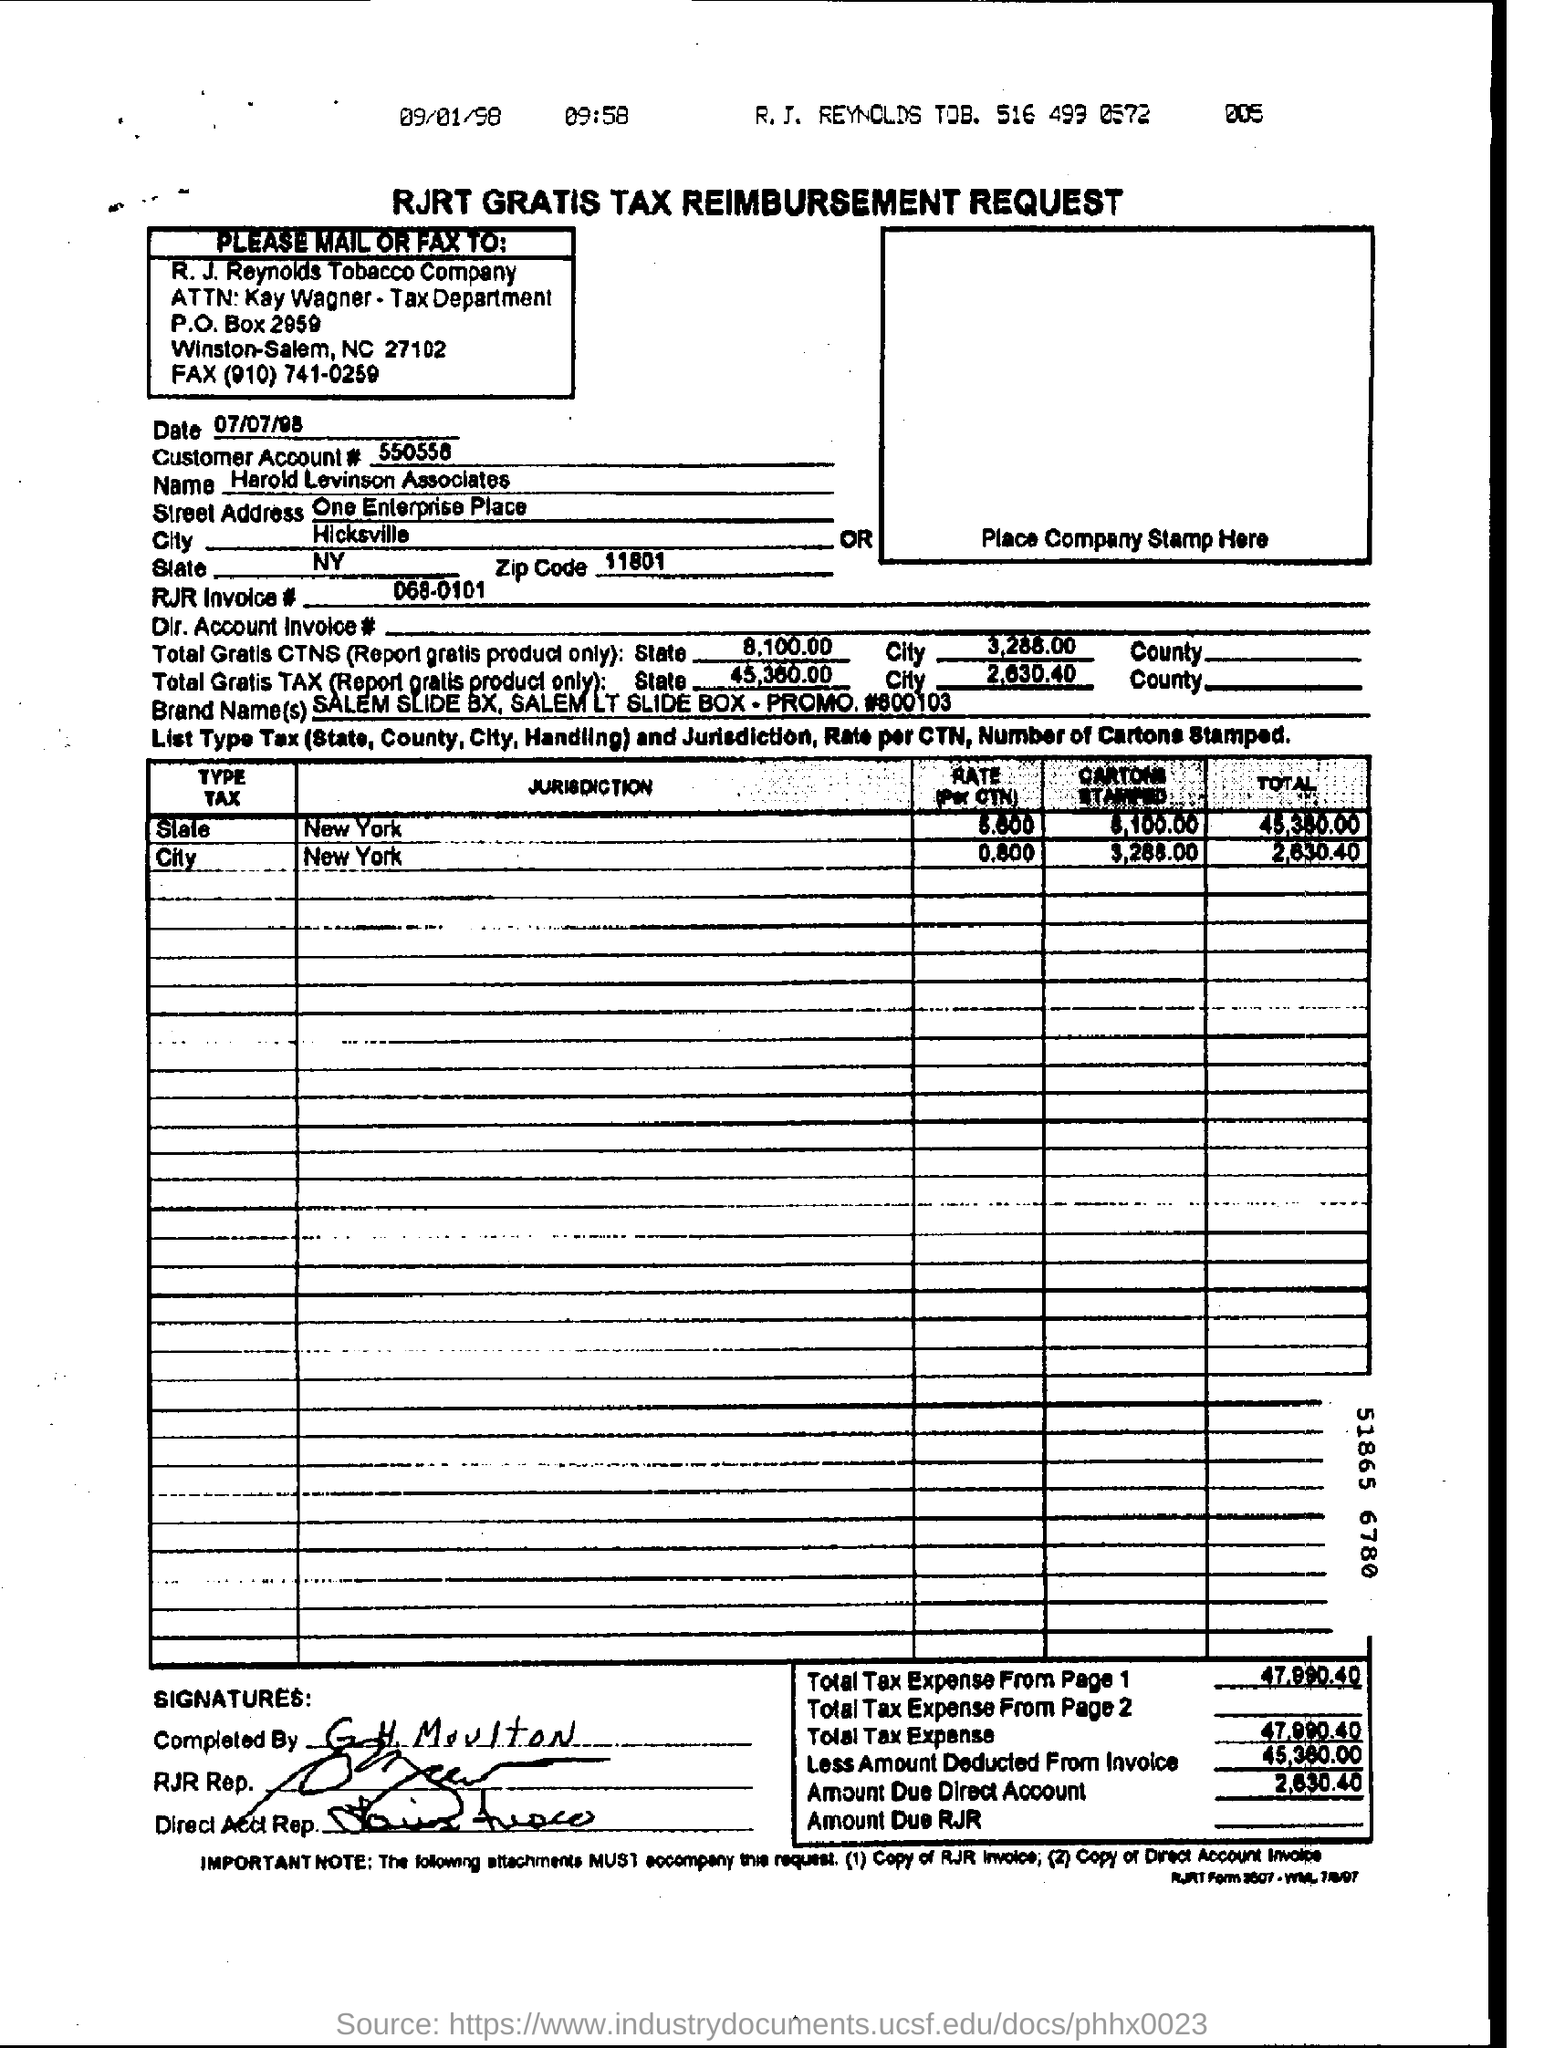Outline some significant characteristics in this image. The zip code mentioned in the form is 11801. The form is dated as of July 7th, 1998. The person who holds the Tax Reimbursement Request Form is Harold Levinson Associates. The city mentioned in the form is Hicksville. The customer account number is 550558. 